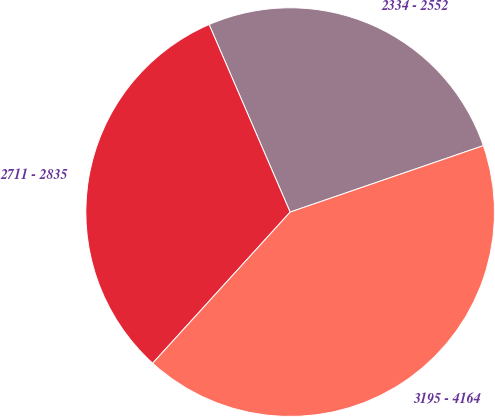<chart> <loc_0><loc_0><loc_500><loc_500><pie_chart><fcel>2334 - 2552<fcel>2711 - 2835<fcel>3195 - 4164<nl><fcel>26.22%<fcel>31.76%<fcel>42.02%<nl></chart> 